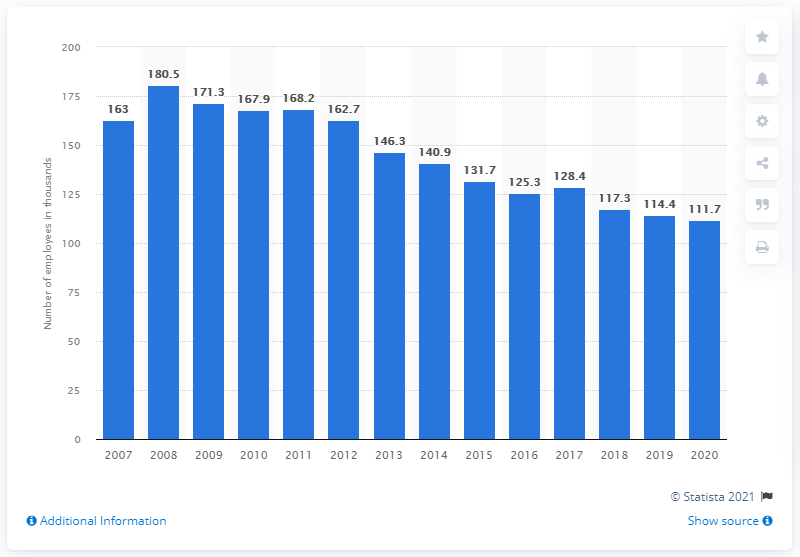Indicate a few pertinent items in this graphic. In recent history, Sony's employment figure reached its lowest point in the year 2020. 